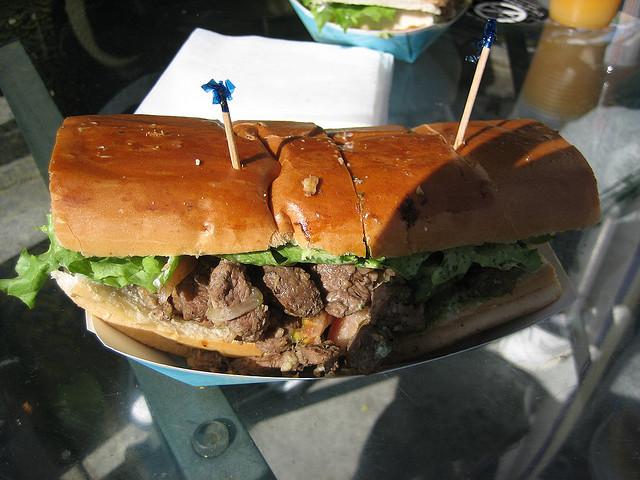Has the sandwich been cut?
Short answer required. Yes. Is there lettuce on the sandwich?
Short answer required. Yes. Is this a Philly cheesesteak?
Answer briefly. No. 